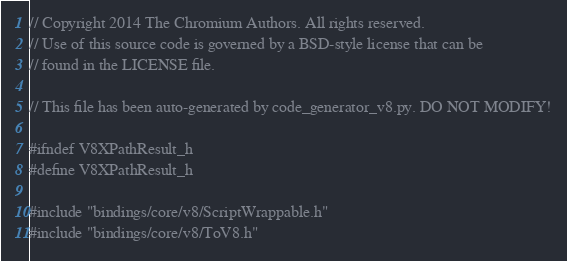Convert code to text. <code><loc_0><loc_0><loc_500><loc_500><_C_>// Copyright 2014 The Chromium Authors. All rights reserved.
// Use of this source code is governed by a BSD-style license that can be
// found in the LICENSE file.

// This file has been auto-generated by code_generator_v8.py. DO NOT MODIFY!

#ifndef V8XPathResult_h
#define V8XPathResult_h

#include "bindings/core/v8/ScriptWrappable.h"
#include "bindings/core/v8/ToV8.h"</code> 